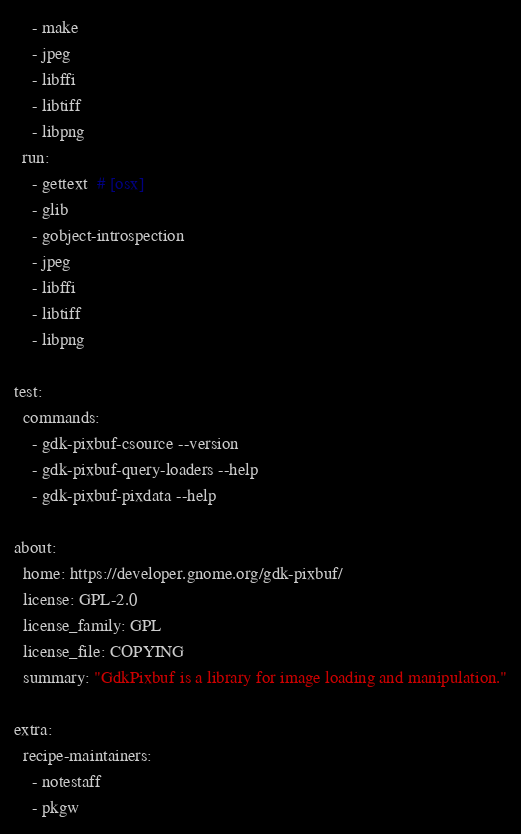<code> <loc_0><loc_0><loc_500><loc_500><_YAML_>    - make
    - jpeg
    - libffi
    - libtiff
    - libpng
  run:
    - gettext  # [osx]
    - glib
    - gobject-introspection
    - jpeg
    - libffi
    - libtiff
    - libpng

test:
  commands:
    - gdk-pixbuf-csource --version
    - gdk-pixbuf-query-loaders --help
    - gdk-pixbuf-pixdata --help

about:
  home: https://developer.gnome.org/gdk-pixbuf/
  license: GPL-2.0
  license_family: GPL
  license_file: COPYING
  summary: "GdkPixbuf is a library for image loading and manipulation."

extra:
  recipe-maintainers:
    - notestaff
    - pkgw
</code> 